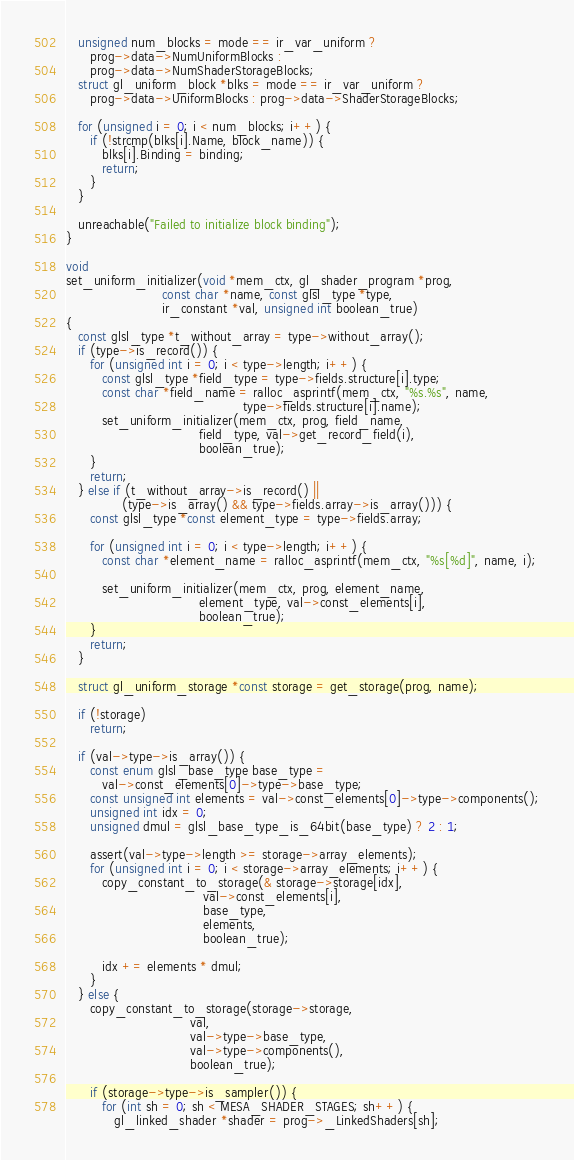<code> <loc_0><loc_0><loc_500><loc_500><_C++_>   unsigned num_blocks = mode == ir_var_uniform ?
      prog->data->NumUniformBlocks :
      prog->data->NumShaderStorageBlocks;
   struct gl_uniform_block *blks = mode == ir_var_uniform ?
      prog->data->UniformBlocks : prog->data->ShaderStorageBlocks;

   for (unsigned i = 0; i < num_blocks; i++) {
      if (!strcmp(blks[i].Name, block_name)) {
         blks[i].Binding = binding;
         return;
      }
   }

   unreachable("Failed to initialize block binding");
}

void
set_uniform_initializer(void *mem_ctx, gl_shader_program *prog,
                        const char *name, const glsl_type *type,
                        ir_constant *val, unsigned int boolean_true)
{
   const glsl_type *t_without_array = type->without_array();
   if (type->is_record()) {
      for (unsigned int i = 0; i < type->length; i++) {
         const glsl_type *field_type = type->fields.structure[i].type;
         const char *field_name = ralloc_asprintf(mem_ctx, "%s.%s", name,
                                            type->fields.structure[i].name);
         set_uniform_initializer(mem_ctx, prog, field_name,
                                 field_type, val->get_record_field(i),
                                 boolean_true);
      }
      return;
   } else if (t_without_array->is_record() ||
              (type->is_array() && type->fields.array->is_array())) {
      const glsl_type *const element_type = type->fields.array;

      for (unsigned int i = 0; i < type->length; i++) {
         const char *element_name = ralloc_asprintf(mem_ctx, "%s[%d]", name, i);

         set_uniform_initializer(mem_ctx, prog, element_name,
                                 element_type, val->const_elements[i],
                                 boolean_true);
      }
      return;
   }

   struct gl_uniform_storage *const storage = get_storage(prog, name);

   if (!storage)
      return;

   if (val->type->is_array()) {
      const enum glsl_base_type base_type =
         val->const_elements[0]->type->base_type;
      const unsigned int elements = val->const_elements[0]->type->components();
      unsigned int idx = 0;
      unsigned dmul = glsl_base_type_is_64bit(base_type) ? 2 : 1;

      assert(val->type->length >= storage->array_elements);
      for (unsigned int i = 0; i < storage->array_elements; i++) {
         copy_constant_to_storage(& storage->storage[idx],
                                  val->const_elements[i],
                                  base_type,
                                  elements,
                                  boolean_true);

         idx += elements * dmul;
      }
   } else {
      copy_constant_to_storage(storage->storage,
                               val,
                               val->type->base_type,
                               val->type->components(),
                               boolean_true);

      if (storage->type->is_sampler()) {
         for (int sh = 0; sh < MESA_SHADER_STAGES; sh++) {
            gl_linked_shader *shader = prog->_LinkedShaders[sh];
</code> 